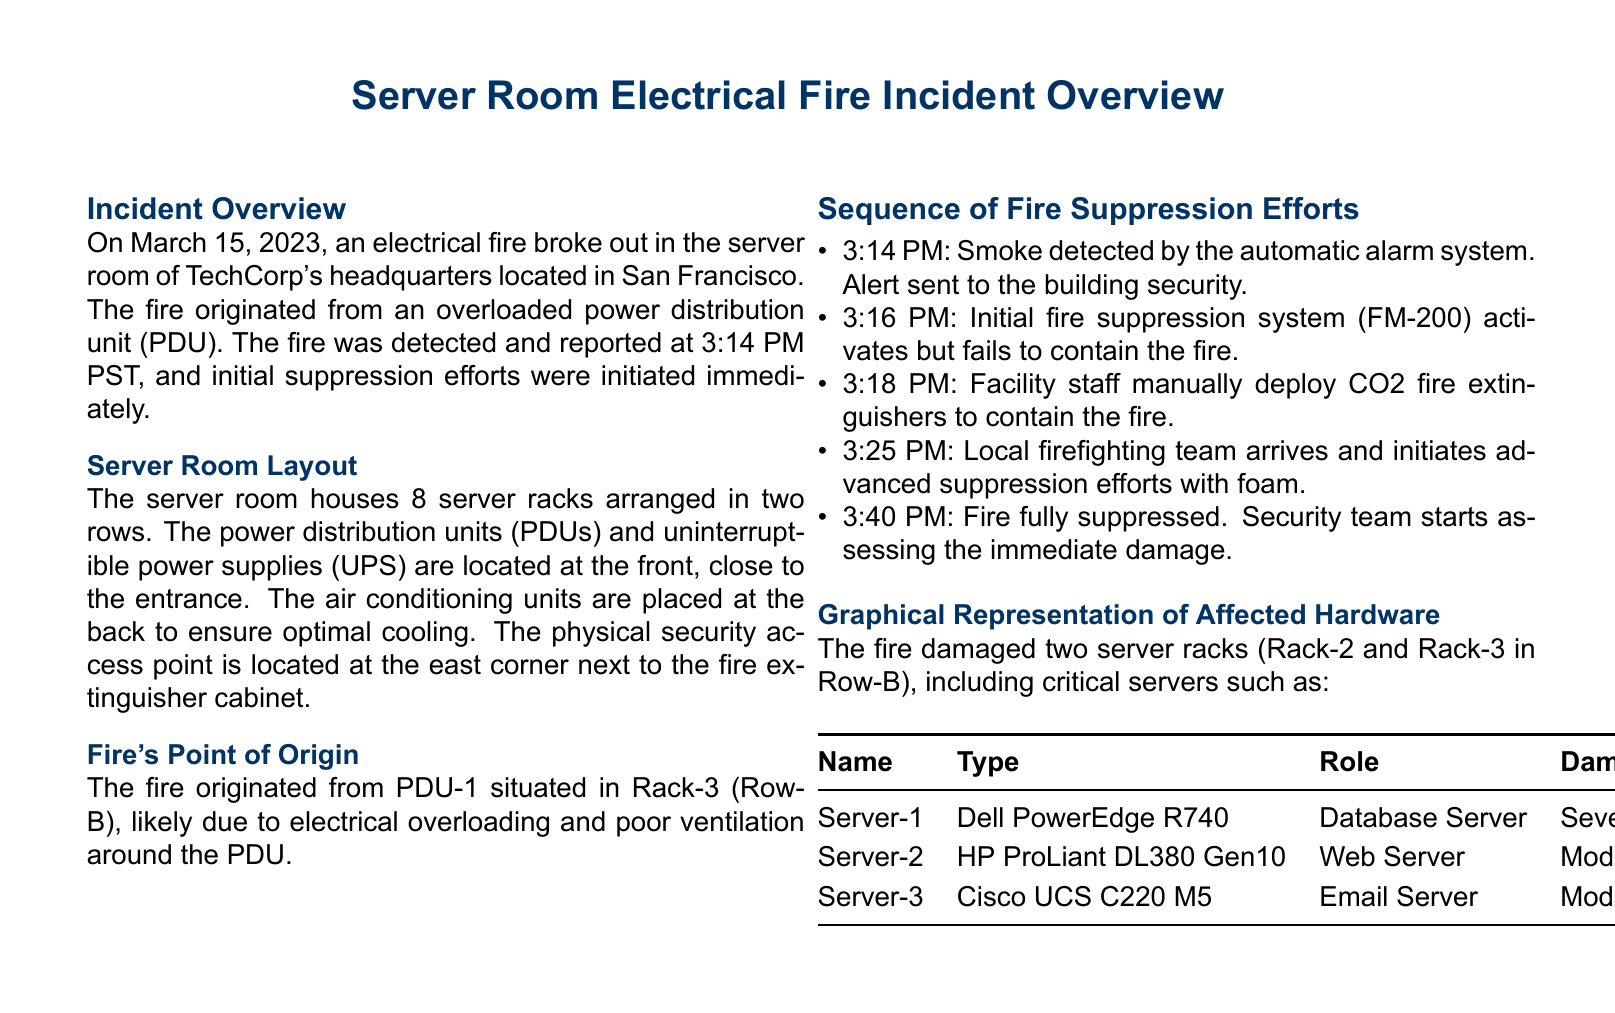What date did the electrical fire occur? The date of the incident is specified in the overview section.
Answer: March 15, 2023 What originated the fire? The cause of the fire is mentioned in the incident overview section.
Answer: Overloaded power distribution unit What was the time of the initial alarm detection? The time of smoke detection is noted in the sequence of fire suppression efforts.
Answer: 3:14 PM How many server racks were damaged? The number of server racks affected is stated in the graphical representation section.
Answer: Two What type of server is Server-1? The type of Server-1 is specified in the graphical representation table.
Answer: Dell PowerEdge R740 What was the role of Server-2? The role of Server-2 is found in the table detailing affected hardware.
Answer: Web Server Which fire suppression system activated first? The first suppression system mentioned in the sequence of fire suppression efforts is noted.
Answer: FM-200 What was used for advanced suppression efforts? The method used by the local firefighting team is detailed in the sequence section.
Answer: Foam Where is the fire extinguisher cabinet located? The location of the fire extinguisher cabinet is mentioned in the server room layout description.
Answer: East corner 